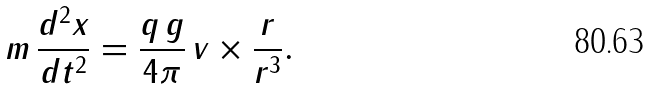<formula> <loc_0><loc_0><loc_500><loc_500>m \, \frac { d ^ { 2 } x } { d t ^ { 2 } } = \frac { q \, g } { 4 \pi } \, v \times \frac { r } { r ^ { 3 } } .</formula> 